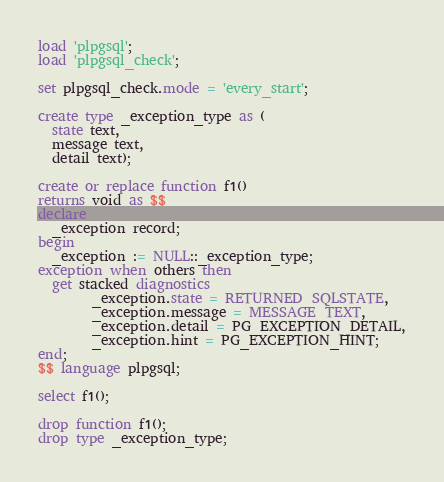Convert code to text. <code><loc_0><loc_0><loc_500><loc_500><_SQL_>load 'plpgsql';
load 'plpgsql_check';

set plpgsql_check.mode = 'every_start';

create type _exception_type as (
  state text,
  message text,
  detail text);

create or replace function f1()
returns void as $$
declare
  _exception record;
begin
  _exception := NULL::_exception_type;
exception when others then
  get stacked diagnostics
        _exception.state = RETURNED_SQLSTATE,
        _exception.message = MESSAGE_TEXT,
        _exception.detail = PG_EXCEPTION_DETAIL,
        _exception.hint = PG_EXCEPTION_HINT;
end;
$$ language plpgsql;

select f1();

drop function f1();
drop type _exception_type;
</code> 